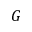Convert formula to latex. <formula><loc_0><loc_0><loc_500><loc_500>G</formula> 